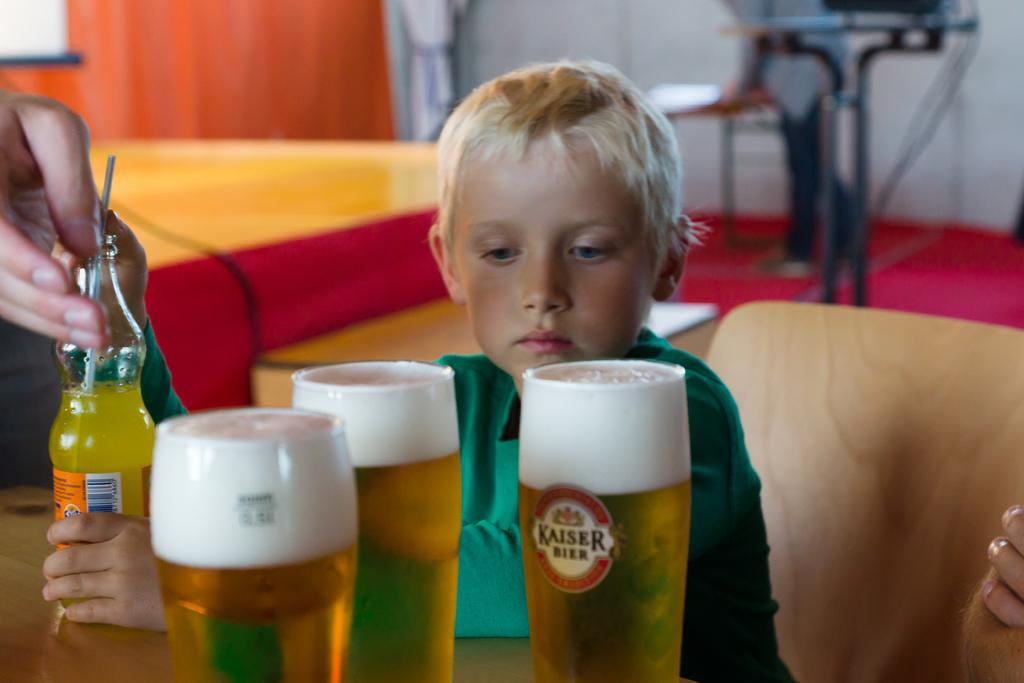<image>
Present a compact description of the photo's key features. A young child staring at three full Kaiser Beer glasses. 